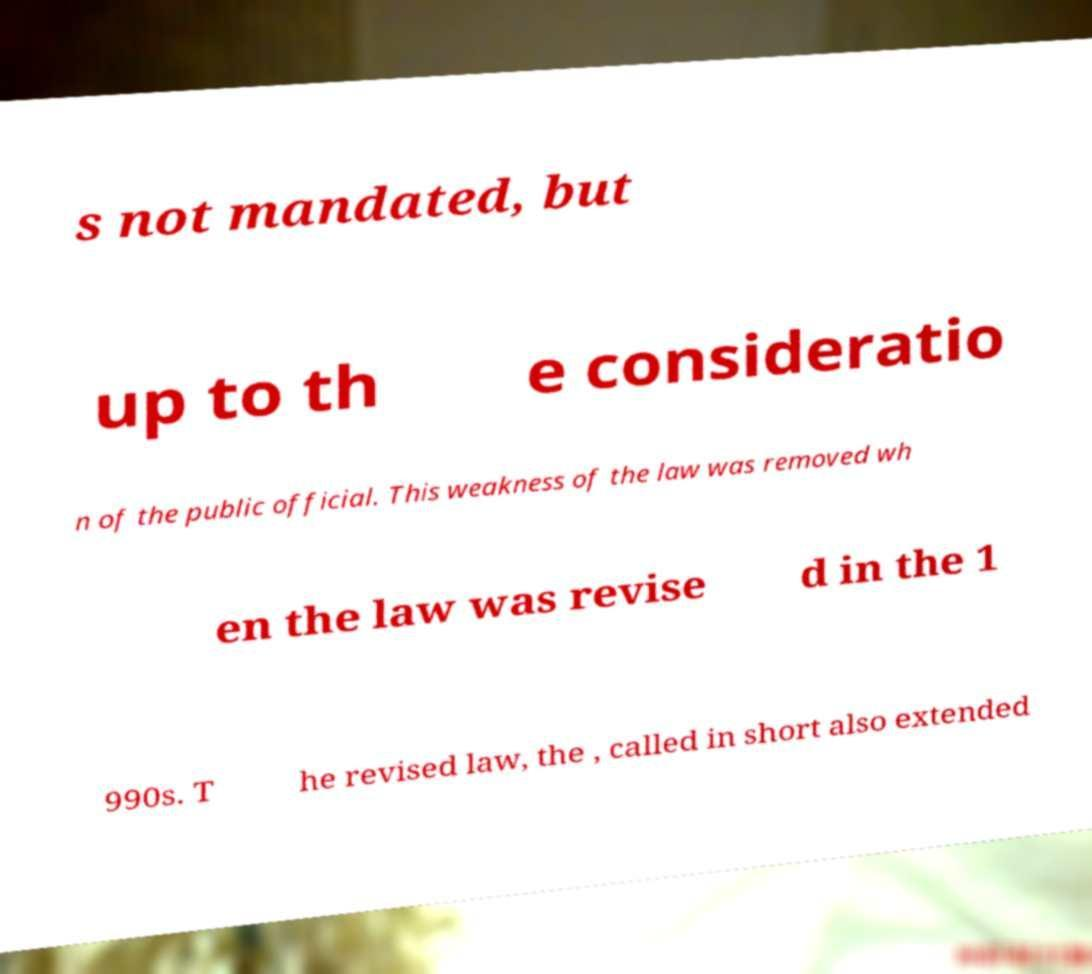I need the written content from this picture converted into text. Can you do that? s not mandated, but up to th e consideratio n of the public official. This weakness of the law was removed wh en the law was revise d in the 1 990s. T he revised law, the , called in short also extended 